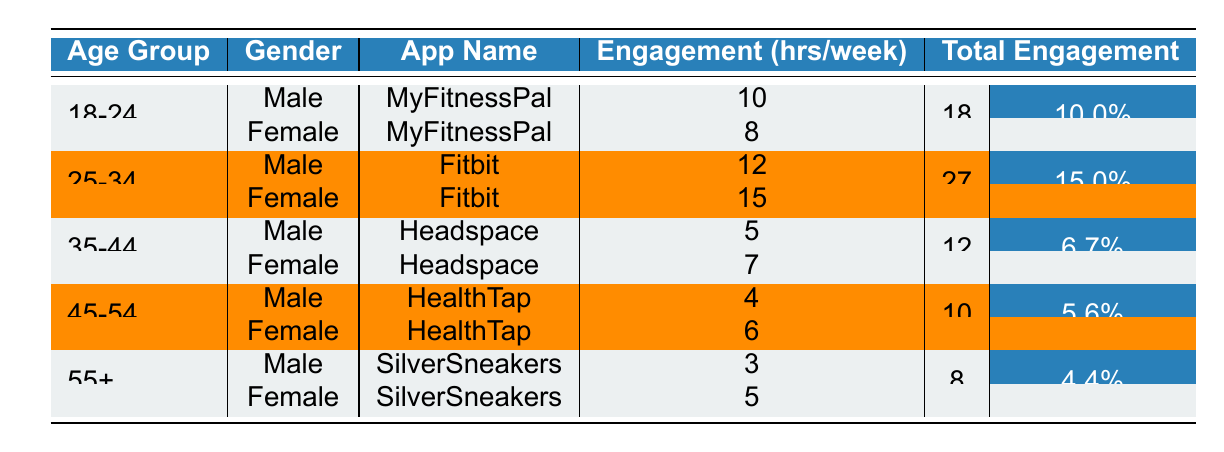What is the average engagement for females in the age group 25-34? To find the average engagement for females aged 25-34, we can look at the row for females in this age group. The engagement hours per week is 15. Since there is only one female entry for this age group, the average is simply 15/1 = 15.
Answer: 15 Which app has the highest engagement hours among males in the age group 18-24? For males aged 18-24, the only app listed is MyFitnessPal with 10 engagement hours per week. There are no other entries for this group. Therefore, it has the highest engagement hours among males in this age group.
Answer: MyFitnessPal Is there any gender difference in the engagement hours for the age group 35-44? In the age group 35-44, males have an engagement of 5 hours while females have 7 hours. Therefore, there is a difference.
Answer: Yes What is the total engagement for the age group 55+? For the age group 55+, the engagement hours are 3 (Males) + 5 (Females) = 8 hours total. We sum the values for both genders to find the total engagement.
Answer: 8 How does the average engagement for the age group 45-54 compare to the age group 25-34? For the 45-54 age group, the engagement is (4 + 6)/2 = 5 hours. For the 25-34 age group, it is (12 + 15)/2 = 13.5 hours. The engagement for 25-34 is higher by 13.5 - 5 = 8.5 hours.
Answer: 8.5 hours What percentage of total engagement does the app Fitbit account for among females? The total engagement hours for females is 8 (MyFitnessPal) + 7 (Headspace) + 6 (HealthTap) + 5 (SilverSneakers) = 26 hours. Fitbit's engagement for females is 15 hours. The percentage can be calculated as (15/26)*100 = 57.69%.
Answer: 57.69% Does the average engagement decrease from the age group 35-44 to 55+ for males? In the age group 35-44, the average engagement for males is 5 hours. For males aged 55+, it is 3 hours. Thus, the average decreases from 5 to 3 hours, confirming a decrease.
Answer: Yes Which app shows the lowest engagement among females across all age groups? Reviewing all female entries, the minimum engagement is 5 hours from the SilverSneakers app in the age group 55+. Thus, this app shows the lowest engagement among females across all groups.
Answer: SilverSneakers 